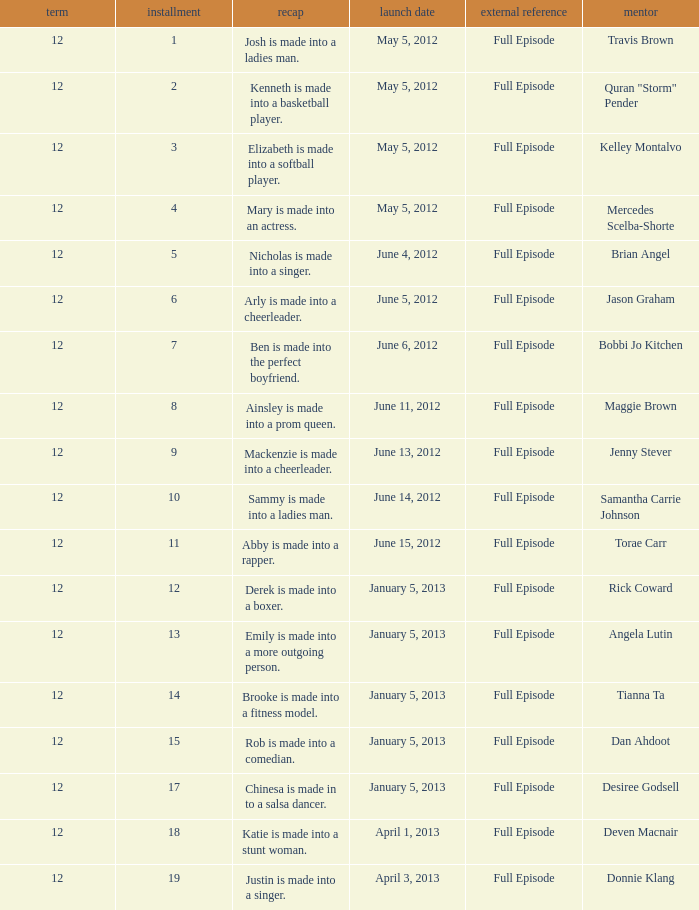Name the episode for travis brown 1.0. 